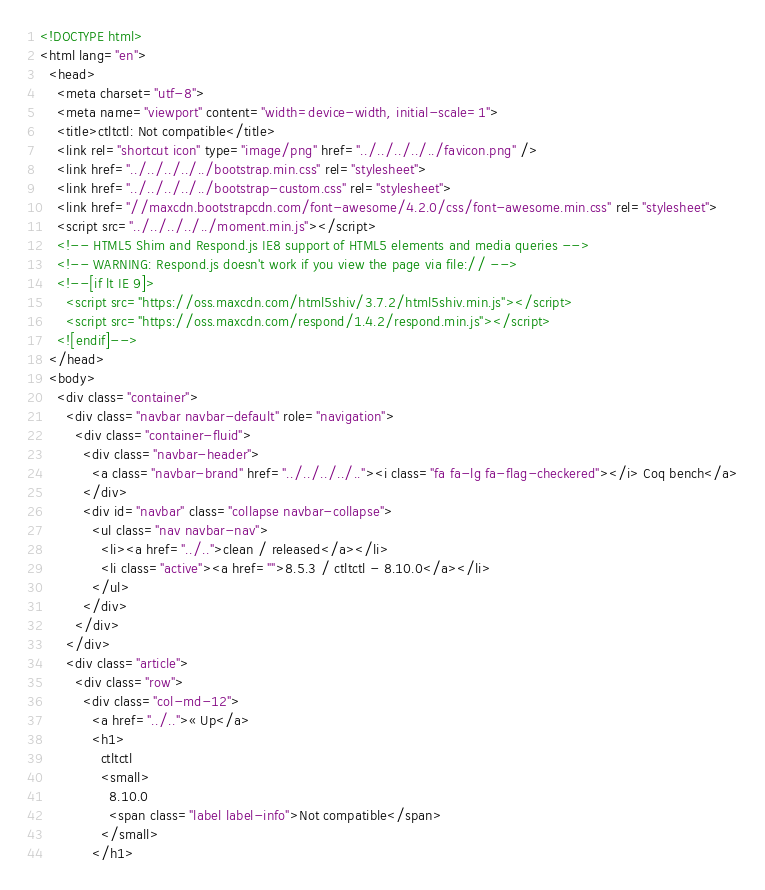Convert code to text. <code><loc_0><loc_0><loc_500><loc_500><_HTML_><!DOCTYPE html>
<html lang="en">
  <head>
    <meta charset="utf-8">
    <meta name="viewport" content="width=device-width, initial-scale=1">
    <title>ctltctl: Not compatible</title>
    <link rel="shortcut icon" type="image/png" href="../../../../../favicon.png" />
    <link href="../../../../../bootstrap.min.css" rel="stylesheet">
    <link href="../../../../../bootstrap-custom.css" rel="stylesheet">
    <link href="//maxcdn.bootstrapcdn.com/font-awesome/4.2.0/css/font-awesome.min.css" rel="stylesheet">
    <script src="../../../../../moment.min.js"></script>
    <!-- HTML5 Shim and Respond.js IE8 support of HTML5 elements and media queries -->
    <!-- WARNING: Respond.js doesn't work if you view the page via file:// -->
    <!--[if lt IE 9]>
      <script src="https://oss.maxcdn.com/html5shiv/3.7.2/html5shiv.min.js"></script>
      <script src="https://oss.maxcdn.com/respond/1.4.2/respond.min.js"></script>
    <![endif]-->
  </head>
  <body>
    <div class="container">
      <div class="navbar navbar-default" role="navigation">
        <div class="container-fluid">
          <div class="navbar-header">
            <a class="navbar-brand" href="../../../../.."><i class="fa fa-lg fa-flag-checkered"></i> Coq bench</a>
          </div>
          <div id="navbar" class="collapse navbar-collapse">
            <ul class="nav navbar-nav">
              <li><a href="../..">clean / released</a></li>
              <li class="active"><a href="">8.5.3 / ctltctl - 8.10.0</a></li>
            </ul>
          </div>
        </div>
      </div>
      <div class="article">
        <div class="row">
          <div class="col-md-12">
            <a href="../..">« Up</a>
            <h1>
              ctltctl
              <small>
                8.10.0
                <span class="label label-info">Not compatible</span>
              </small>
            </h1></code> 